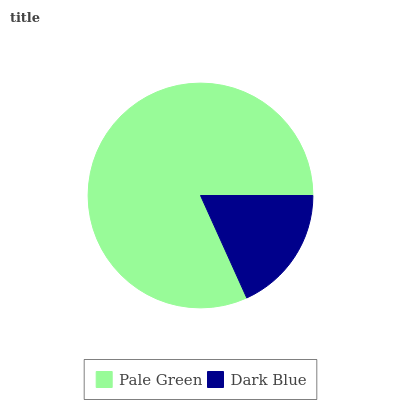Is Dark Blue the minimum?
Answer yes or no. Yes. Is Pale Green the maximum?
Answer yes or no. Yes. Is Dark Blue the maximum?
Answer yes or no. No. Is Pale Green greater than Dark Blue?
Answer yes or no. Yes. Is Dark Blue less than Pale Green?
Answer yes or no. Yes. Is Dark Blue greater than Pale Green?
Answer yes or no. No. Is Pale Green less than Dark Blue?
Answer yes or no. No. Is Pale Green the high median?
Answer yes or no. Yes. Is Dark Blue the low median?
Answer yes or no. Yes. Is Dark Blue the high median?
Answer yes or no. No. Is Pale Green the low median?
Answer yes or no. No. 